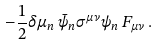Convert formula to latex. <formula><loc_0><loc_0><loc_500><loc_500>- \frac { 1 } { 2 } \delta \mu _ { n } \, \bar { \psi } _ { n } \sigma ^ { \mu \nu } \psi _ { n } \, F _ { \mu \nu } \, .</formula> 